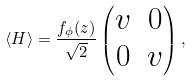<formula> <loc_0><loc_0><loc_500><loc_500>\langle H \rangle = \frac { f _ { \phi } ( z ) } { \sqrt { 2 } } \begin{pmatrix} v & 0 \\ 0 & v \end{pmatrix} ,</formula> 